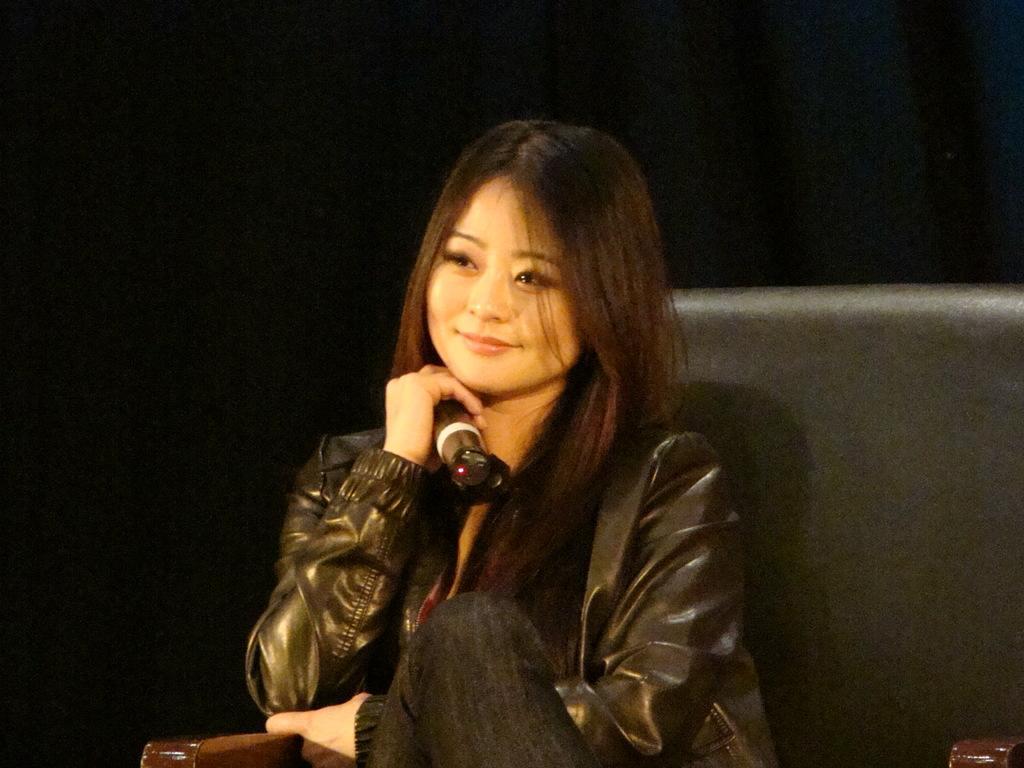How would you summarize this image in a sentence or two? In this image in the center there is one woman who is sitting in a chair, and she is holding a mike and there is a black background. 